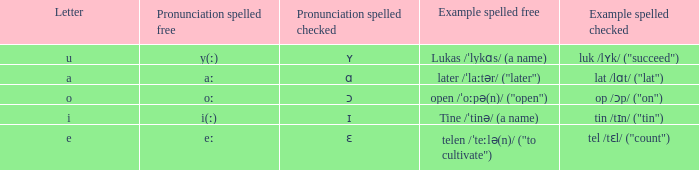What is Pronunciation Spelled Free, when Pronunciation Spelled Checked is "ɑ"? Aː. 